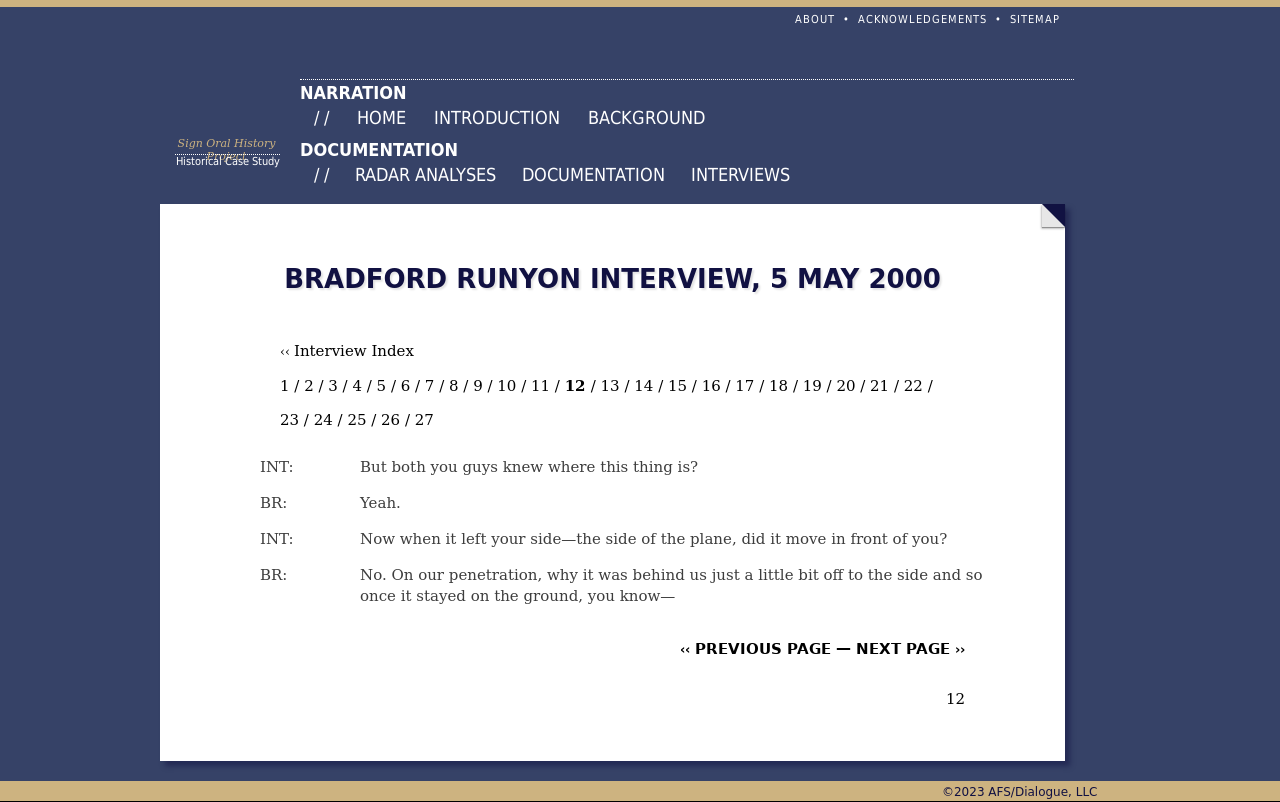Describe the design and layout of the webpage shown in the image. The webpage shown in the image has a clean and organized layout, featuring a top navigation bar with links to various sections such as Home, Introduction, Documentation, and Interviews. The main content area displays the transcript of an interview titled 'Bradford Runyan Interview, 5 May 2000', clearly sectioned with pagination. The design uses a muted color palette with a dark blue header, and light text background, ensuring readability and a professional appearance. 